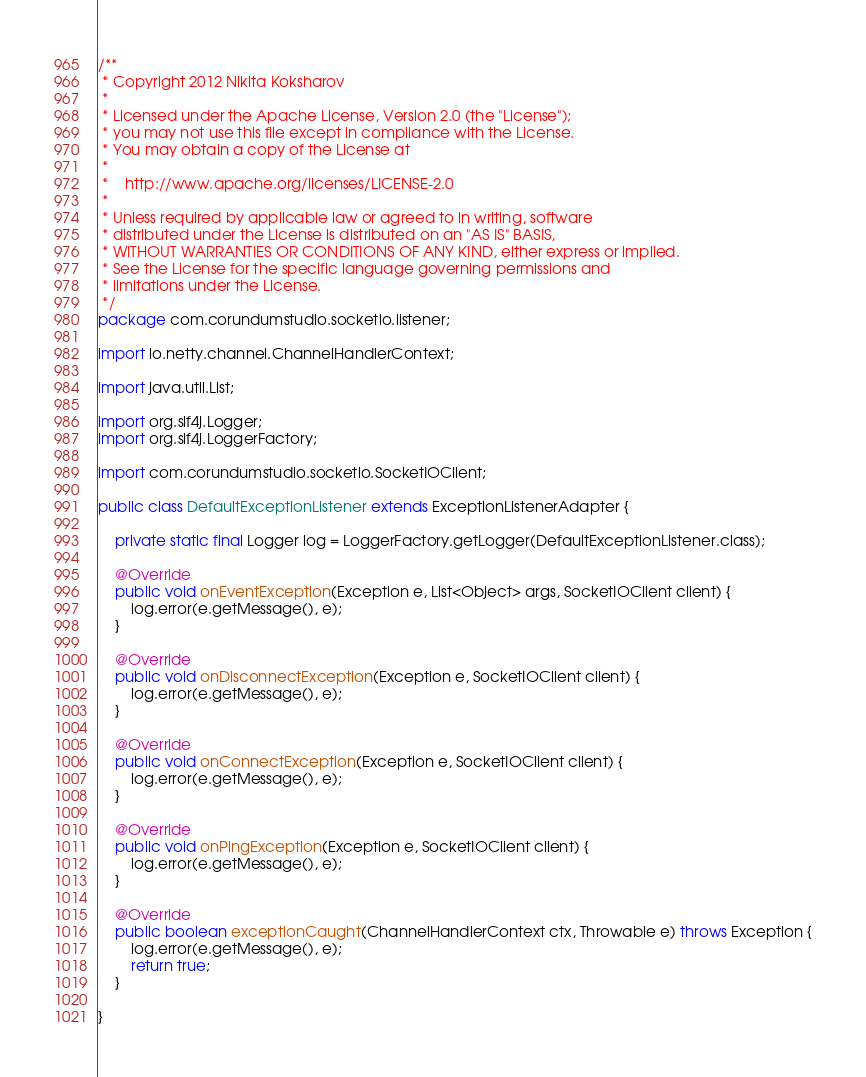Convert code to text. <code><loc_0><loc_0><loc_500><loc_500><_Java_>/**
 * Copyright 2012 Nikita Koksharov
 *
 * Licensed under the Apache License, Version 2.0 (the "License");
 * you may not use this file except in compliance with the License.
 * You may obtain a copy of the License at
 *
 *    http://www.apache.org/licenses/LICENSE-2.0
 *
 * Unless required by applicable law or agreed to in writing, software
 * distributed under the License is distributed on an "AS IS" BASIS,
 * WITHOUT WARRANTIES OR CONDITIONS OF ANY KIND, either express or implied.
 * See the License for the specific language governing permissions and
 * limitations under the License.
 */
package com.corundumstudio.socketio.listener;

import io.netty.channel.ChannelHandlerContext;

import java.util.List;

import org.slf4j.Logger;
import org.slf4j.LoggerFactory;

import com.corundumstudio.socketio.SocketIOClient;

public class DefaultExceptionListener extends ExceptionListenerAdapter {

    private static final Logger log = LoggerFactory.getLogger(DefaultExceptionListener.class);

    @Override
    public void onEventException(Exception e, List<Object> args, SocketIOClient client) {
        log.error(e.getMessage(), e);
    }

    @Override
    public void onDisconnectException(Exception e, SocketIOClient client) {
        log.error(e.getMessage(), e);
    }

    @Override
    public void onConnectException(Exception e, SocketIOClient client) {
        log.error(e.getMessage(), e);
    }

    @Override
    public void onPingException(Exception e, SocketIOClient client) {
        log.error(e.getMessage(), e);
    }

    @Override
    public boolean exceptionCaught(ChannelHandlerContext ctx, Throwable e) throws Exception {
        log.error(e.getMessage(), e);
        return true;
    }

}
</code> 